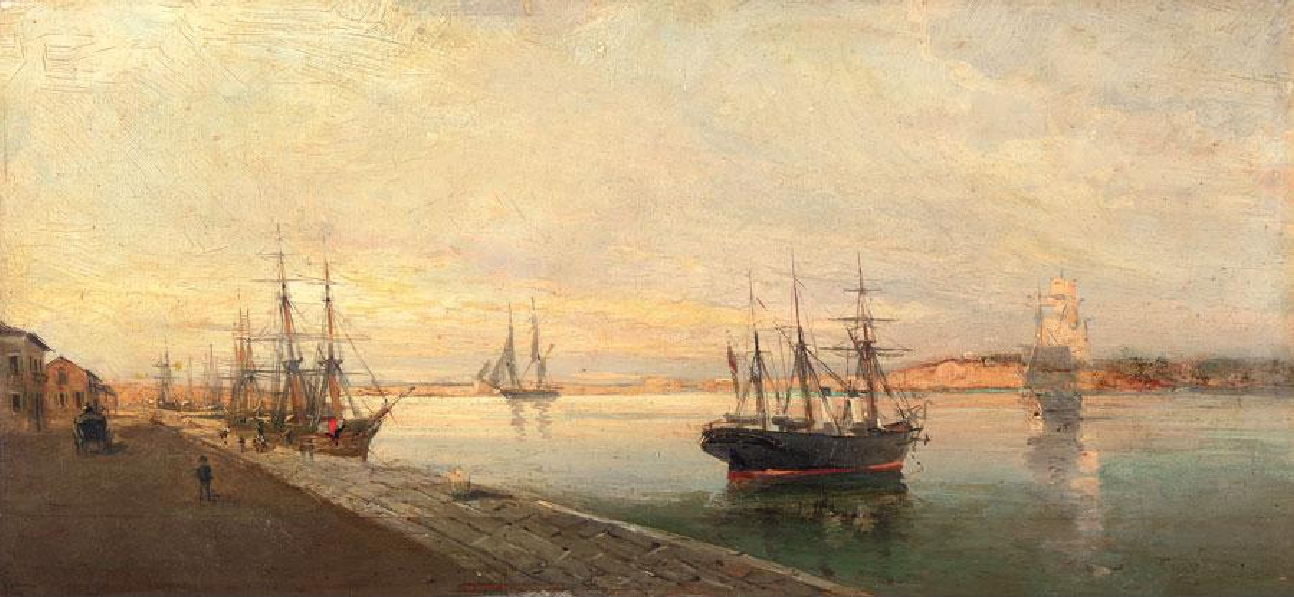Explain the visual content of the image in great detail. The image exhibits an oil painting of a serene harbor at what appears to be the cusp of either dawn or dusk, given the diffused light that bathes the sky in a soft melange of pinks, blues, and oranges. This time of day suggests a peaceful moment before the activity of the harbor comes to life or as it's winding down. Emphasis is placed on three-masted sailing ships docked at the quay, hinting at the era before industrialization revolutionized maritime transport.

In the foreground, various figures are depicted in mid-motion, some seemingly focused on their labors pertaining to the vessels while others are strolling leisurely, captured in a freeze-frame of everyday life. On the right, a lighthouse stands as a guardian of the harbor. The painter employs brisk, textured brushstrokes that convey movement and vibrancy, while the water reflects the warmth of the sky, creating a harmonious balance between sky and sea. The painting is reminiscent of the works of Impressionist masters who found beauty in ordinary scenes, portraying them with an eye for the transient effects of light and color. 